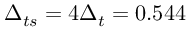<formula> <loc_0><loc_0><loc_500><loc_500>\Delta _ { t s } = 4 \Delta _ { t } = 0 . 5 4 4</formula> 